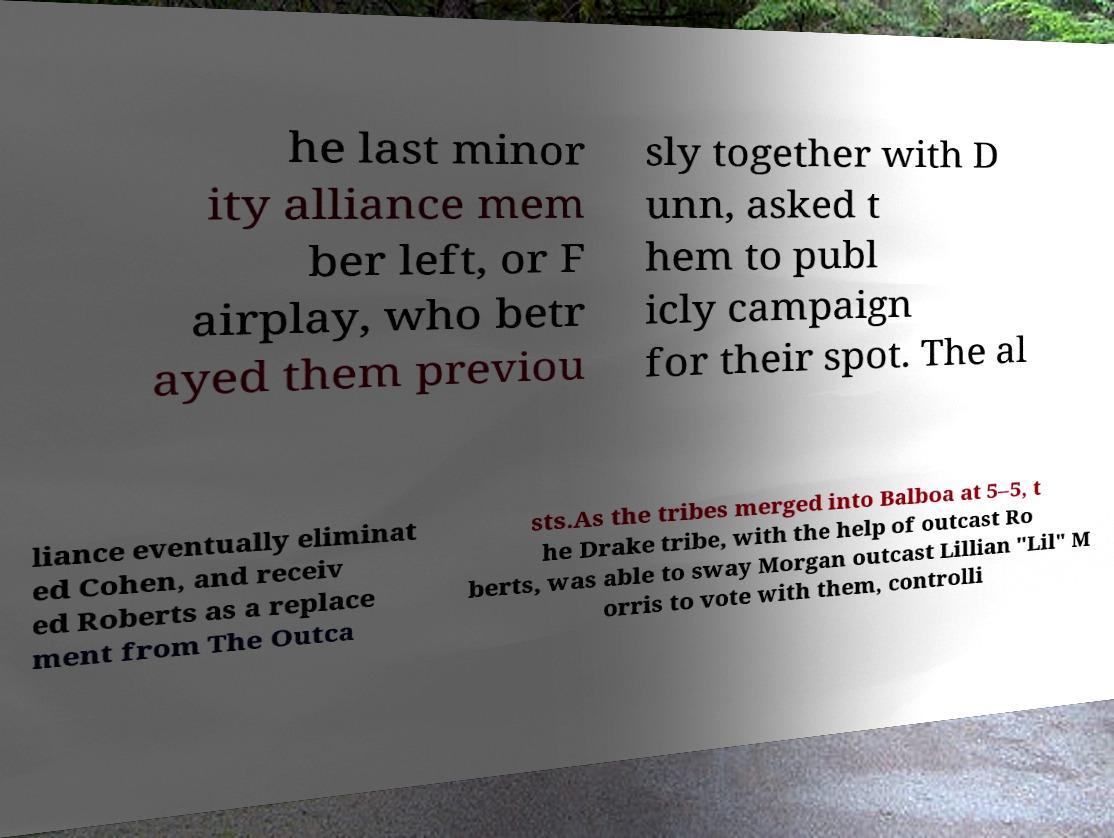Can you read and provide the text displayed in the image?This photo seems to have some interesting text. Can you extract and type it out for me? he last minor ity alliance mem ber left, or F airplay, who betr ayed them previou sly together with D unn, asked t hem to publ icly campaign for their spot. The al liance eventually eliminat ed Cohen, and receiv ed Roberts as a replace ment from The Outca sts.As the tribes merged into Balboa at 5–5, t he Drake tribe, with the help of outcast Ro berts, was able to sway Morgan outcast Lillian "Lil" M orris to vote with them, controlli 